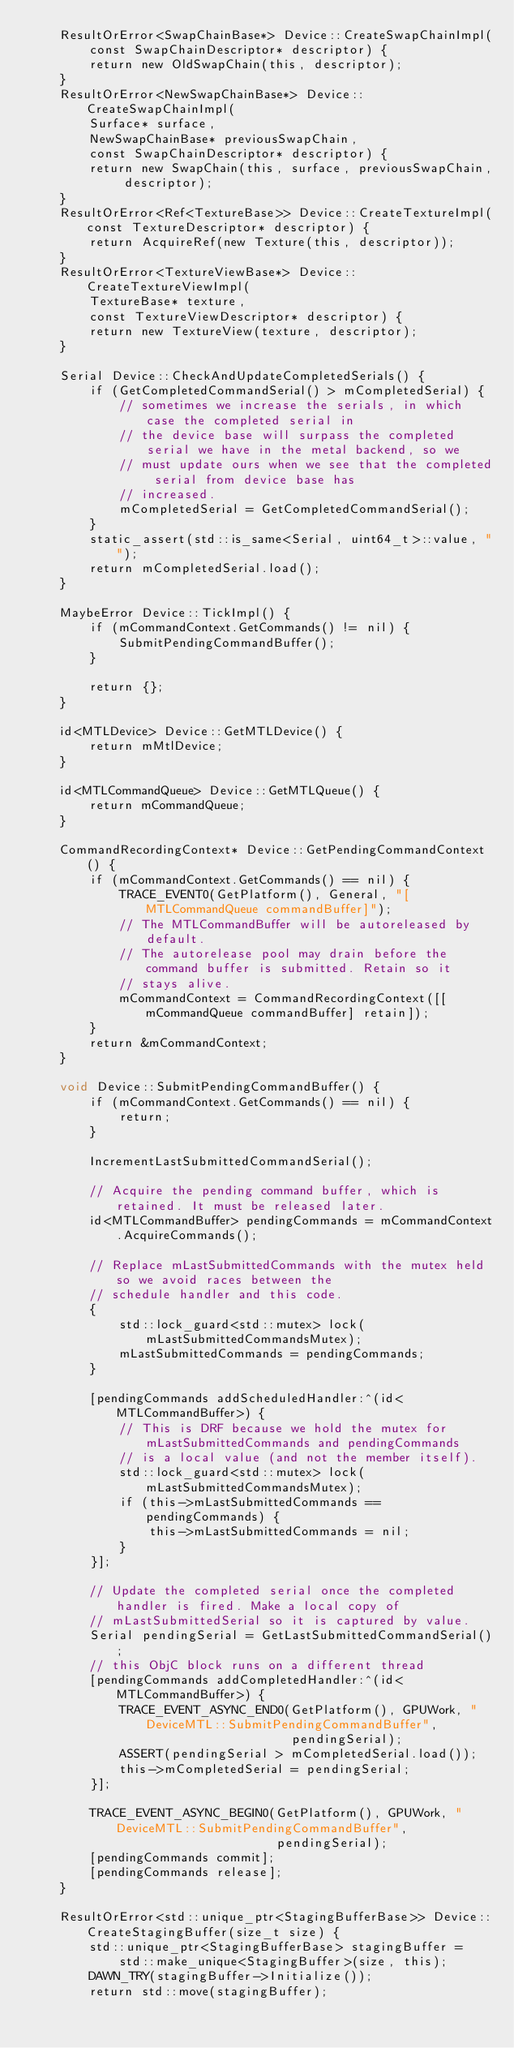Convert code to text. <code><loc_0><loc_0><loc_500><loc_500><_ObjectiveC_>    ResultOrError<SwapChainBase*> Device::CreateSwapChainImpl(
        const SwapChainDescriptor* descriptor) {
        return new OldSwapChain(this, descriptor);
    }
    ResultOrError<NewSwapChainBase*> Device::CreateSwapChainImpl(
        Surface* surface,
        NewSwapChainBase* previousSwapChain,
        const SwapChainDescriptor* descriptor) {
        return new SwapChain(this, surface, previousSwapChain, descriptor);
    }
    ResultOrError<Ref<TextureBase>> Device::CreateTextureImpl(const TextureDescriptor* descriptor) {
        return AcquireRef(new Texture(this, descriptor));
    }
    ResultOrError<TextureViewBase*> Device::CreateTextureViewImpl(
        TextureBase* texture,
        const TextureViewDescriptor* descriptor) {
        return new TextureView(texture, descriptor);
    }

    Serial Device::CheckAndUpdateCompletedSerials() {
        if (GetCompletedCommandSerial() > mCompletedSerial) {
            // sometimes we increase the serials, in which case the completed serial in
            // the device base will surpass the completed serial we have in the metal backend, so we
            // must update ours when we see that the completed serial from device base has
            // increased.
            mCompletedSerial = GetCompletedCommandSerial();
        }
        static_assert(std::is_same<Serial, uint64_t>::value, "");
        return mCompletedSerial.load();
    }

    MaybeError Device::TickImpl() {
        if (mCommandContext.GetCommands() != nil) {
            SubmitPendingCommandBuffer();
        }

        return {};
    }

    id<MTLDevice> Device::GetMTLDevice() {
        return mMtlDevice;
    }

    id<MTLCommandQueue> Device::GetMTLQueue() {
        return mCommandQueue;
    }

    CommandRecordingContext* Device::GetPendingCommandContext() {
        if (mCommandContext.GetCommands() == nil) {
            TRACE_EVENT0(GetPlatform(), General, "[MTLCommandQueue commandBuffer]");
            // The MTLCommandBuffer will be autoreleased by default.
            // The autorelease pool may drain before the command buffer is submitted. Retain so it
            // stays alive.
            mCommandContext = CommandRecordingContext([[mCommandQueue commandBuffer] retain]);
        }
        return &mCommandContext;
    }

    void Device::SubmitPendingCommandBuffer() {
        if (mCommandContext.GetCommands() == nil) {
            return;
        }

        IncrementLastSubmittedCommandSerial();

        // Acquire the pending command buffer, which is retained. It must be released later.
        id<MTLCommandBuffer> pendingCommands = mCommandContext.AcquireCommands();

        // Replace mLastSubmittedCommands with the mutex held so we avoid races between the
        // schedule handler and this code.
        {
            std::lock_guard<std::mutex> lock(mLastSubmittedCommandsMutex);
            mLastSubmittedCommands = pendingCommands;
        }

        [pendingCommands addScheduledHandler:^(id<MTLCommandBuffer>) {
            // This is DRF because we hold the mutex for mLastSubmittedCommands and pendingCommands
            // is a local value (and not the member itself).
            std::lock_guard<std::mutex> lock(mLastSubmittedCommandsMutex);
            if (this->mLastSubmittedCommands == pendingCommands) {
                this->mLastSubmittedCommands = nil;
            }
        }];

        // Update the completed serial once the completed handler is fired. Make a local copy of
        // mLastSubmittedSerial so it is captured by value.
        Serial pendingSerial = GetLastSubmittedCommandSerial();
        // this ObjC block runs on a different thread
        [pendingCommands addCompletedHandler:^(id<MTLCommandBuffer>) {
            TRACE_EVENT_ASYNC_END0(GetPlatform(), GPUWork, "DeviceMTL::SubmitPendingCommandBuffer",
                                   pendingSerial);
            ASSERT(pendingSerial > mCompletedSerial.load());
            this->mCompletedSerial = pendingSerial;
        }];

        TRACE_EVENT_ASYNC_BEGIN0(GetPlatform(), GPUWork, "DeviceMTL::SubmitPendingCommandBuffer",
                                 pendingSerial);
        [pendingCommands commit];
        [pendingCommands release];
    }

    ResultOrError<std::unique_ptr<StagingBufferBase>> Device::CreateStagingBuffer(size_t size) {
        std::unique_ptr<StagingBufferBase> stagingBuffer =
            std::make_unique<StagingBuffer>(size, this);
        DAWN_TRY(stagingBuffer->Initialize());
        return std::move(stagingBuffer);</code> 